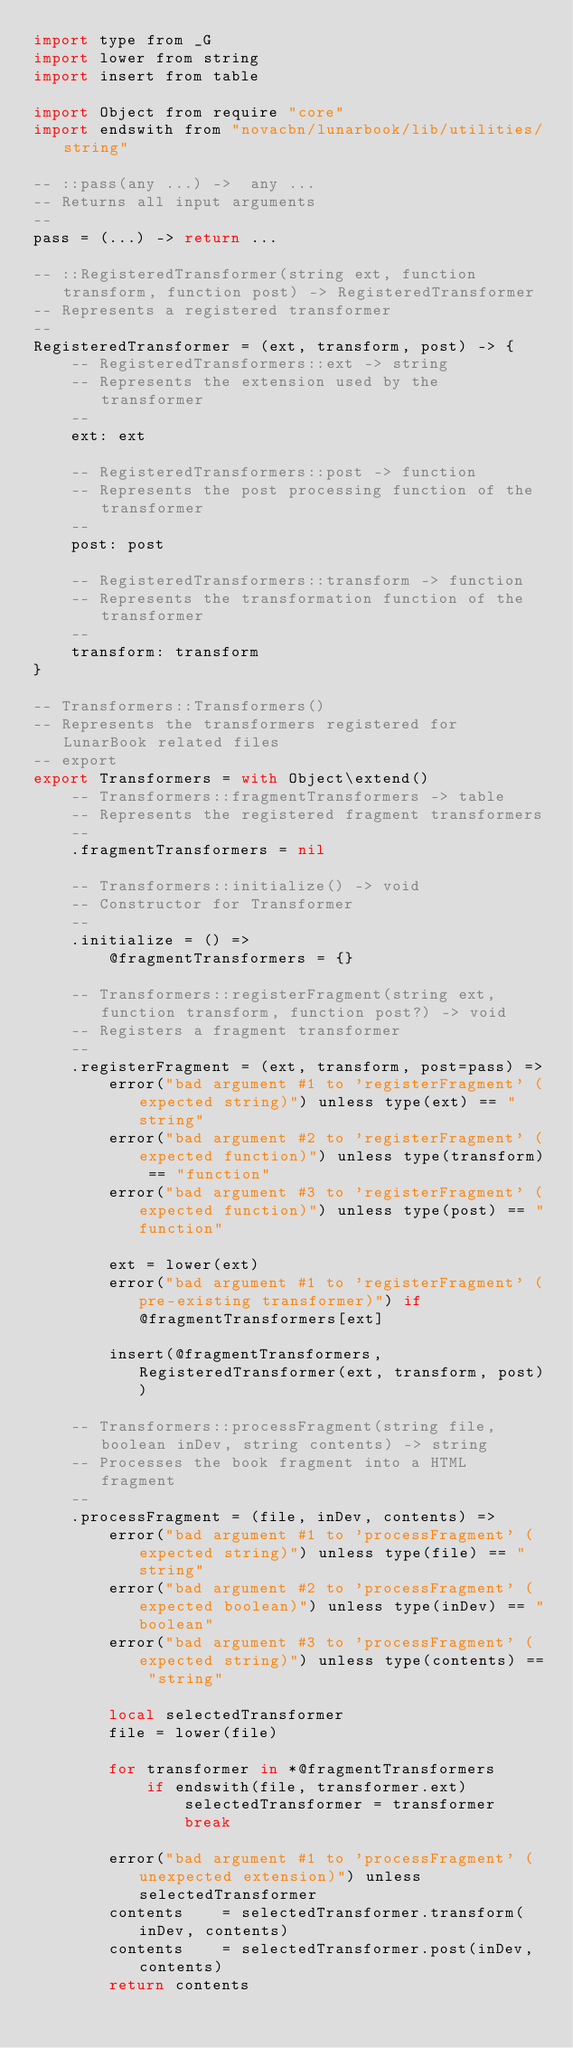<code> <loc_0><loc_0><loc_500><loc_500><_MoonScript_>import type from _G
import lower from string
import insert from table

import Object from require "core"
import endswith from "novacbn/lunarbook/lib/utilities/string"

-- ::pass(any ...) ->  any ...
-- Returns all input arguments
--
pass = (...) -> return ...

-- ::RegisteredTransformer(string ext, function transform, function post) -> RegisteredTransformer
-- Represents a registered transformer
--
RegisteredTransformer = (ext, transform, post) -> {
    -- RegisteredTransformers::ext -> string
    -- Represents the extension used by the transformer
    --
    ext: ext

    -- RegisteredTransformers::post -> function
    -- Represents the post processing function of the transformer
    --
    post: post

    -- RegisteredTransformers::transform -> function
    -- Represents the transformation function of the transformer
    --
    transform: transform
}

-- Transformers::Transformers()
-- Represents the transformers registered for LunarBook related files
-- export
export Transformers = with Object\extend()
    -- Transformers::fragmentTransformers -> table
    -- Represents the registered fragment transformers
    --
    .fragmentTransformers = nil

    -- Transformers::initialize() -> void
    -- Constructor for Transformer
    --
    .initialize = () =>
        @fragmentTransformers = {}

    -- Transformers::registerFragment(string ext, function transform, function post?) -> void
    -- Registers a fragment transformer
    --
    .registerFragment = (ext, transform, post=pass) =>
        error("bad argument #1 to 'registerFragment' (expected string)") unless type(ext) == "string"
        error("bad argument #2 to 'registerFragment' (expected function)") unless type(transform) == "function"
        error("bad argument #3 to 'registerFragment' (expected function)") unless type(post) == "function"

        ext = lower(ext)
        error("bad argument #1 to 'registerFragment' (pre-existing transformer)") if @fragmentTransformers[ext]

        insert(@fragmentTransformers, RegisteredTransformer(ext, transform, post))

    -- Transformers::processFragment(string file, boolean inDev, string contents) -> string
    -- Processes the book fragment into a HTML fragment
    --
    .processFragment = (file, inDev, contents) =>
        error("bad argument #1 to 'processFragment' (expected string)") unless type(file) == "string"
        error("bad argument #2 to 'processFragment' (expected boolean)") unless type(inDev) == "boolean"
        error("bad argument #3 to 'processFragment' (expected string)") unless type(contents) == "string"

        local selectedTransformer
        file = lower(file)

        for transformer in *@fragmentTransformers
            if endswith(file, transformer.ext)
                selectedTransformer = transformer
                break

        error("bad argument #1 to 'processFragment' (unexpected extension)") unless selectedTransformer
        contents    = selectedTransformer.transform(inDev, contents)
        contents    = selectedTransformer.post(inDev, contents)
        return contents</code> 